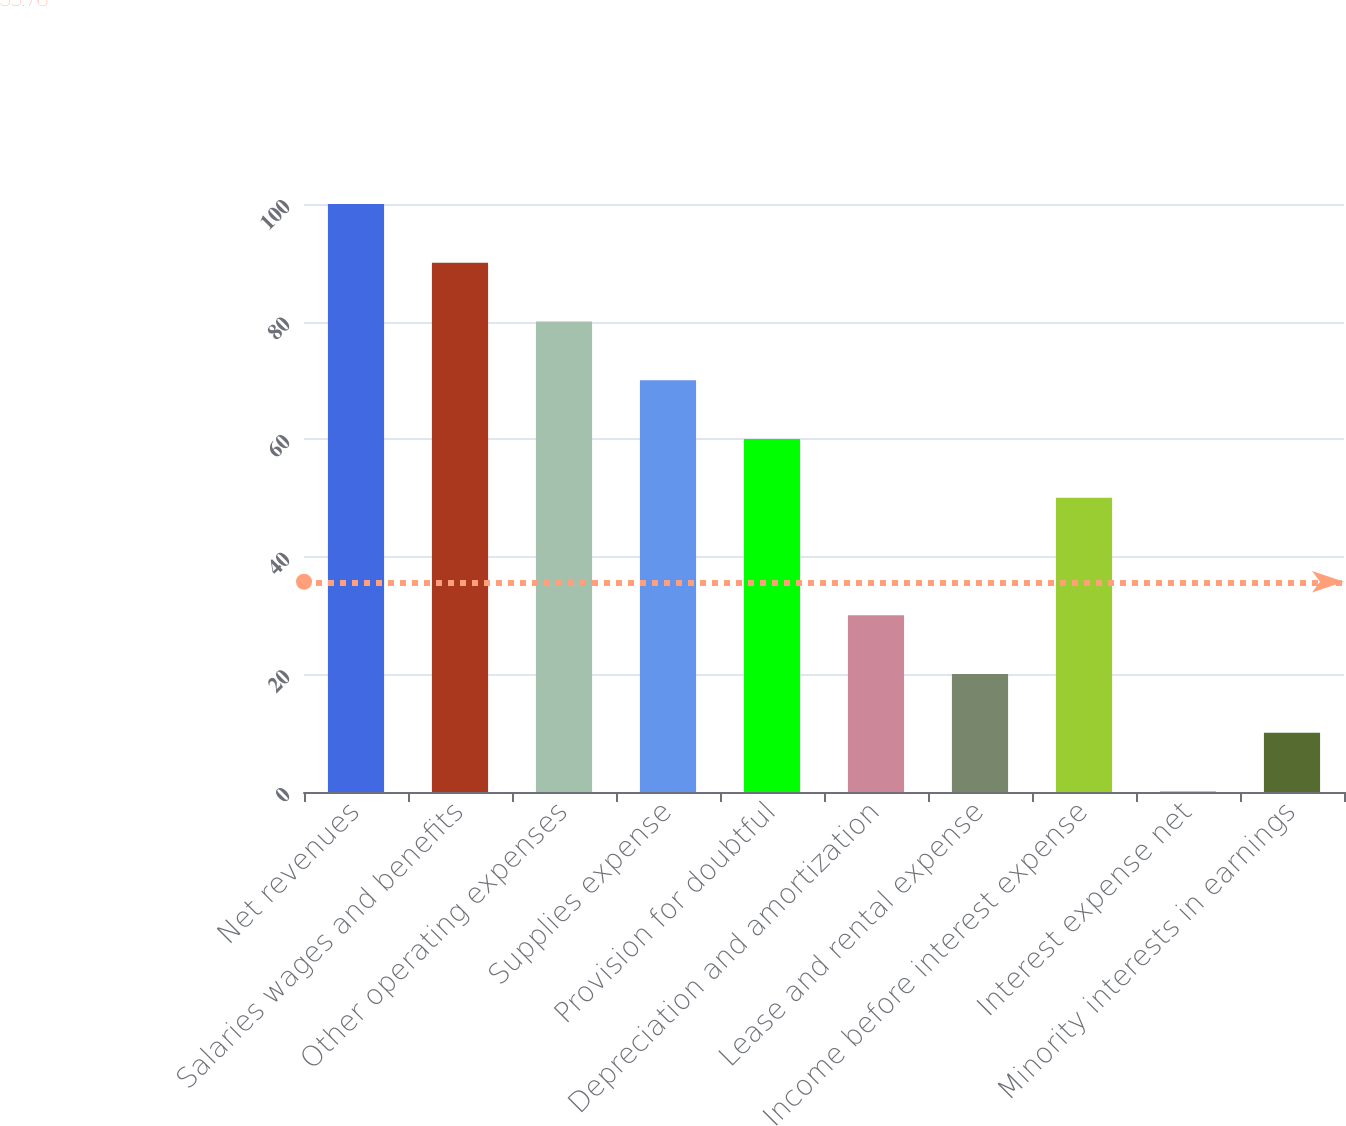<chart> <loc_0><loc_0><loc_500><loc_500><bar_chart><fcel>Net revenues<fcel>Salaries wages and benefits<fcel>Other operating expenses<fcel>Supplies expense<fcel>Provision for doubtful<fcel>Depreciation and amortization<fcel>Lease and rental expense<fcel>Income before interest expense<fcel>Interest expense net<fcel>Minority interests in earnings<nl><fcel>100<fcel>90.01<fcel>80.02<fcel>70.03<fcel>60.04<fcel>30.07<fcel>20.08<fcel>50.05<fcel>0.1<fcel>10.09<nl></chart> 